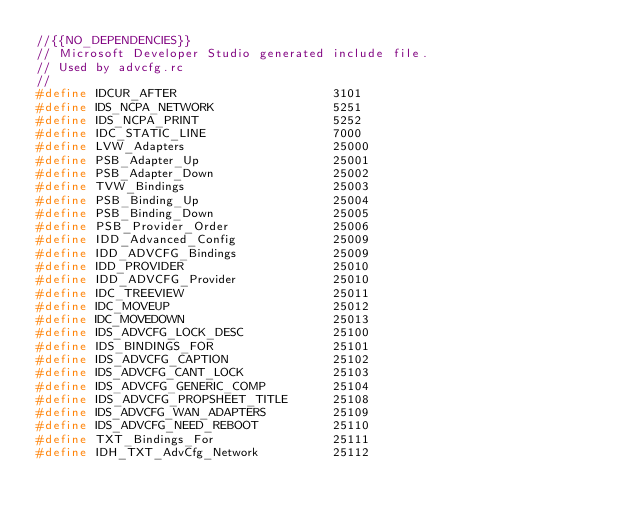Convert code to text. <code><loc_0><loc_0><loc_500><loc_500><_C_>//{{NO_DEPENDENCIES}}
// Microsoft Developer Studio generated include file.
// Used by advcfg.rc
//
#define IDCUR_AFTER                     3101
#define IDS_NCPA_NETWORK                5251
#define IDS_NCPA_PRINT                  5252
#define IDC_STATIC_LINE                 7000
#define LVW_Adapters                    25000
#define PSB_Adapter_Up                  25001
#define PSB_Adapter_Down                25002
#define TVW_Bindings                    25003
#define PSB_Binding_Up                  25004
#define PSB_Binding_Down                25005
#define PSB_Provider_Order              25006
#define IDD_Advanced_Config             25009
#define IDD_ADVCFG_Bindings             25009
#define IDD_PROVIDER                    25010
#define IDD_ADVCFG_Provider             25010
#define IDC_TREEVIEW                    25011
#define IDC_MOVEUP                      25012
#define IDC_MOVEDOWN                    25013
#define IDS_ADVCFG_LOCK_DESC            25100
#define IDS_BINDINGS_FOR                25101
#define IDS_ADVCFG_CAPTION              25102
#define IDS_ADVCFG_CANT_LOCK            25103
#define IDS_ADVCFG_GENERIC_COMP         25104
#define IDS_ADVCFG_PROPSHEET_TITLE      25108
#define IDS_ADVCFG_WAN_ADAPTERS         25109
#define IDS_ADVCFG_NEED_REBOOT          25110
#define TXT_Bindings_For                25111
#define IDH_TXT_AdvCfg_Network          25112</code> 